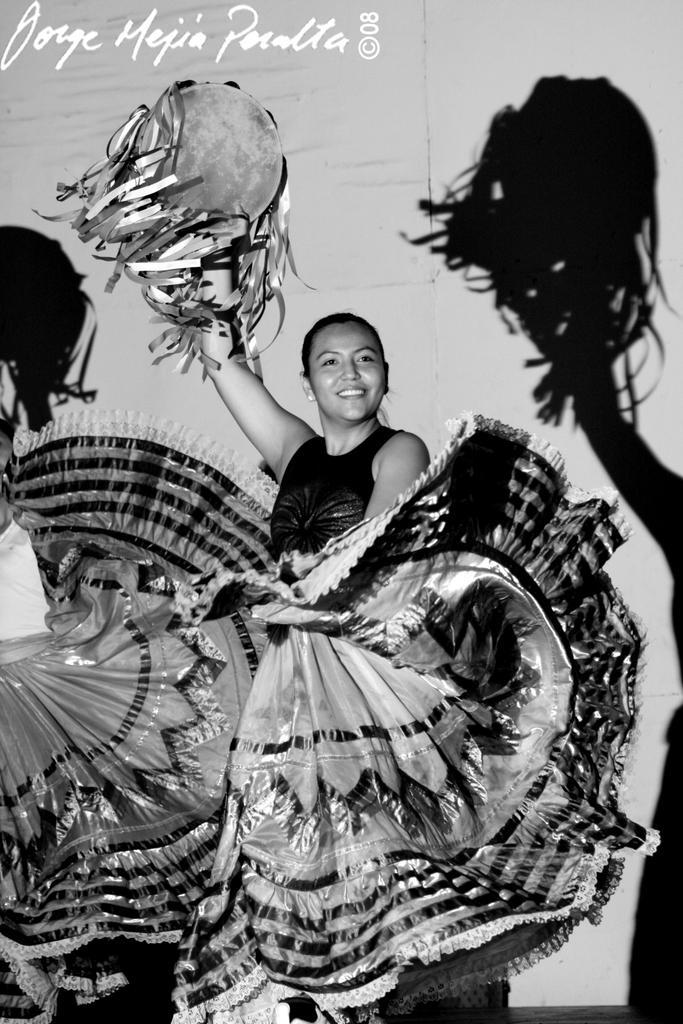Describe this image in one or two sentences. There is a black and white image. In this image, there is a person standing and wearing clothes. This person is holding something with her hand. 